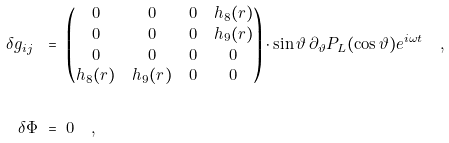<formula> <loc_0><loc_0><loc_500><loc_500>\delta g _ { i j } \ & = \ \begin{pmatrix} 0 & 0 & 0 & h _ { 8 } ( r ) \\ 0 & 0 & 0 & h _ { 9 } ( r ) \\ 0 & 0 & 0 & 0 \\ h _ { 8 } ( r ) & h _ { 9 } ( r ) & 0 & 0 \end{pmatrix} \cdot \sin \vartheta \, \partial _ { \vartheta } P _ { L } ( \cos \vartheta ) e ^ { i \omega t } \quad , \\ \\ \delta \Phi \ & = \ 0 \quad ,</formula> 